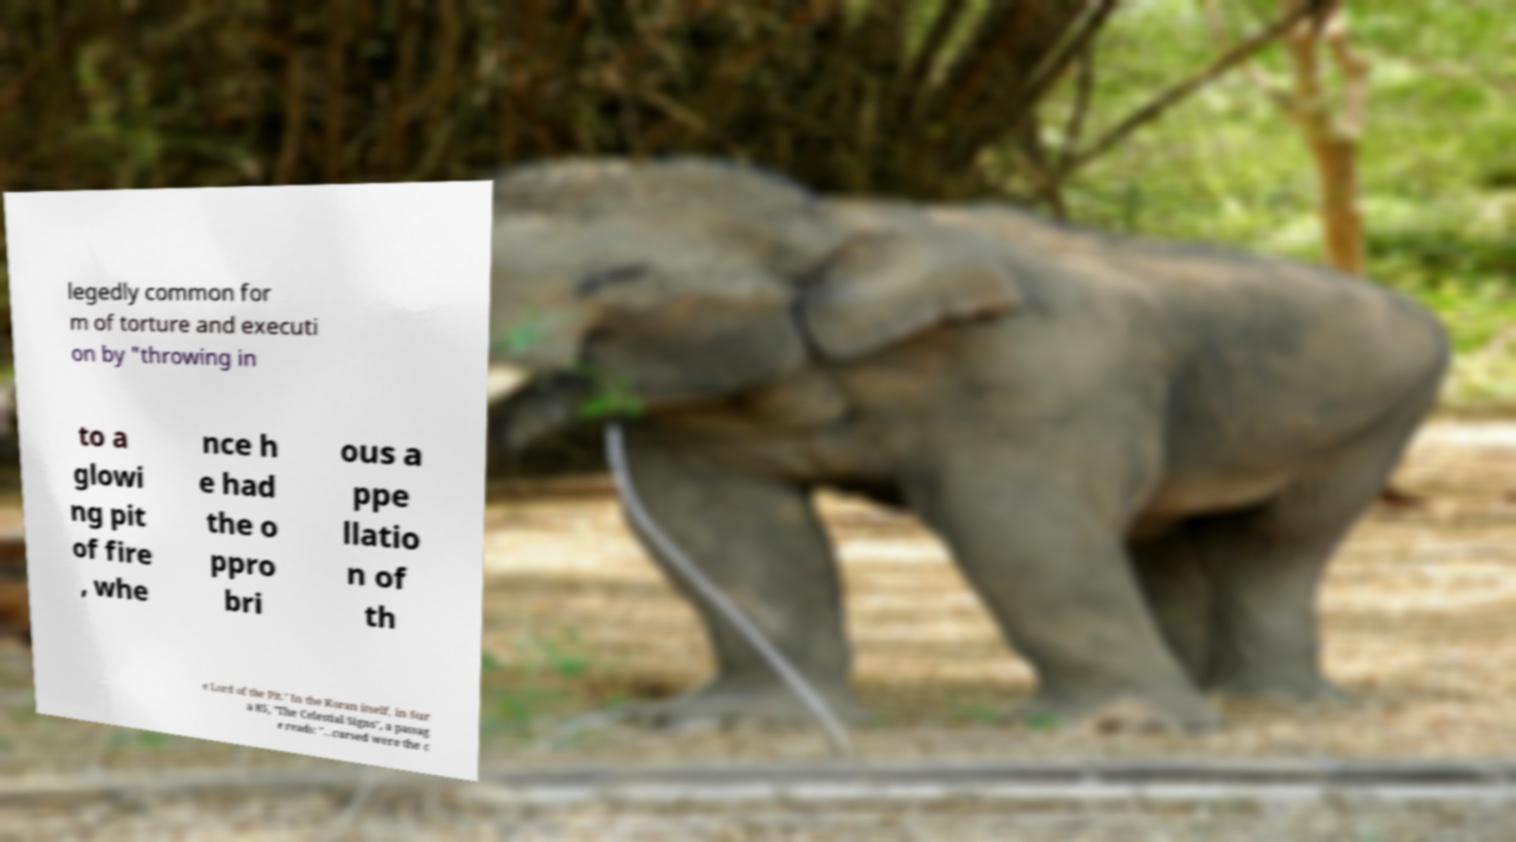For documentation purposes, I need the text within this image transcribed. Could you provide that? legedly common for m of torture and executi on by "throwing in to a glowi ng pit of fire , whe nce h e had the o ppro bri ous a ppe llatio n of th e Lord of the Pit." In the Koran itself, in Sur a 85, "The Celestial Signs", a passag e reads: "...cursed were the c 